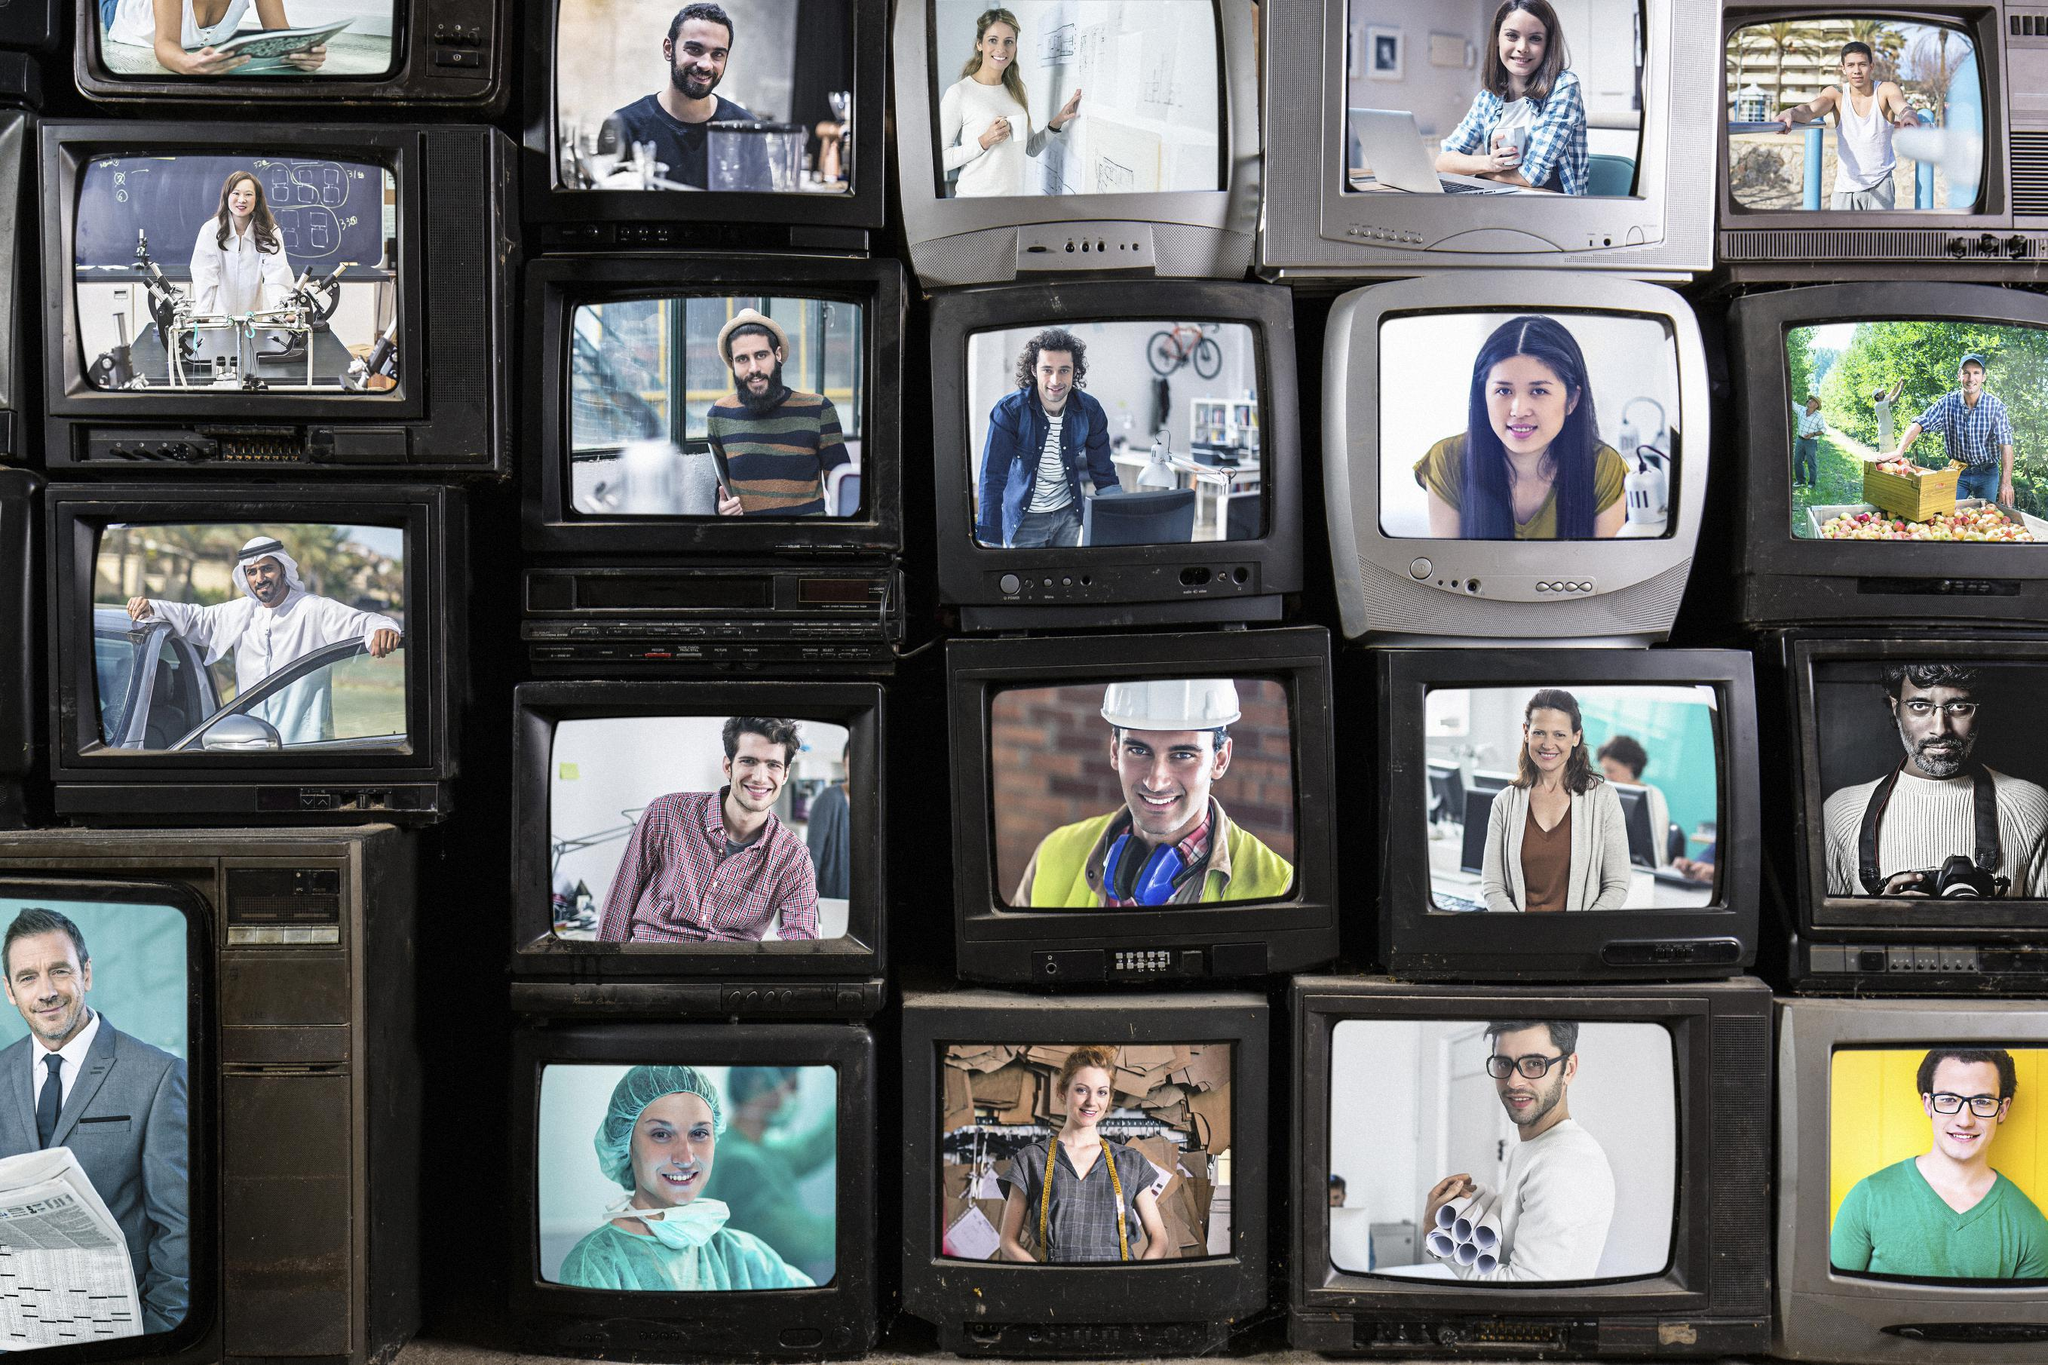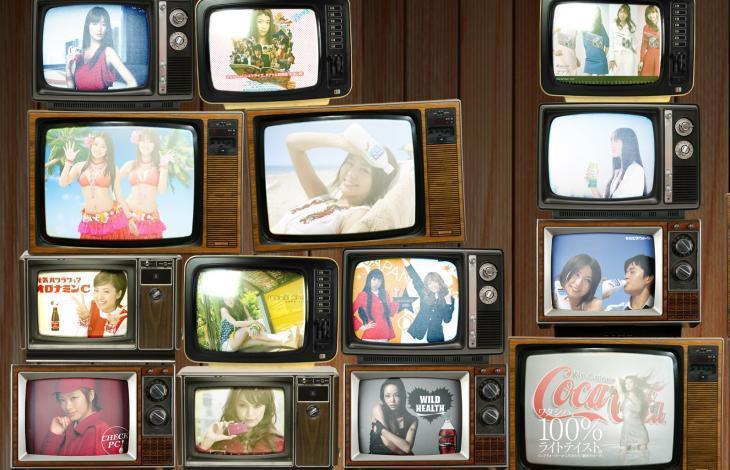The first image is the image on the left, the second image is the image on the right. For the images displayed, is the sentence "In one image, the restaurant with overhead television screens has seating on tall stools at tables with wooden tops." factually correct? Answer yes or no. No. The first image is the image on the left, the second image is the image on the right. Assess this claim about the two images: "An image shows at least one customer in a bar equipped with a suspended TV screen.". Correct or not? Answer yes or no. No. 